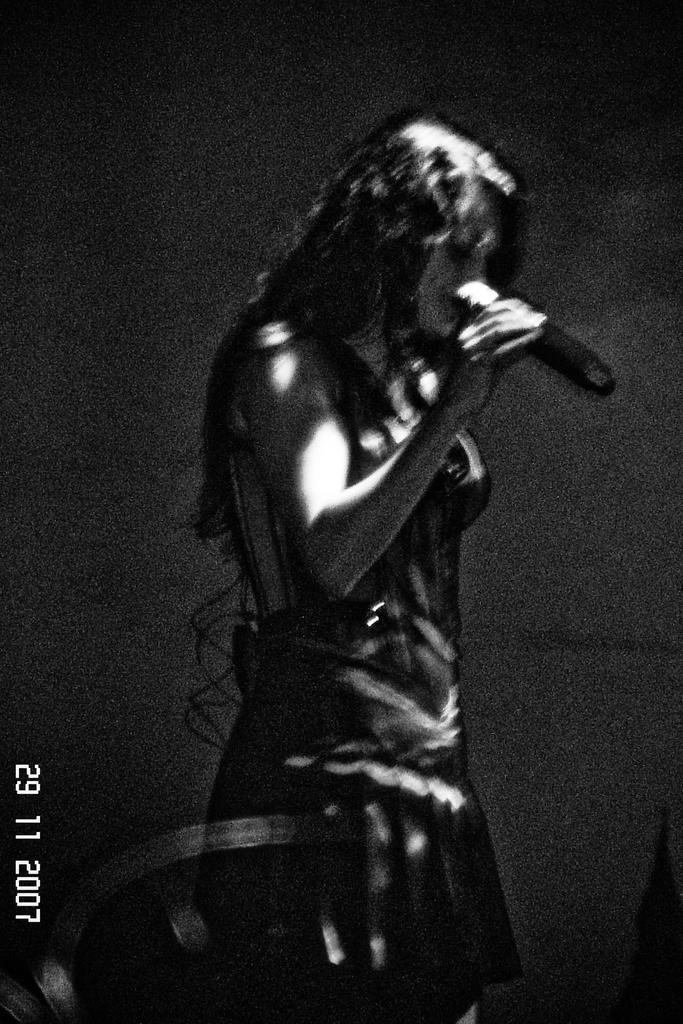Please provide a concise description of this image. This is a black and white image where I can see a person standing here is holding a mic and here I can see the watermark in the left side corner of the image. 